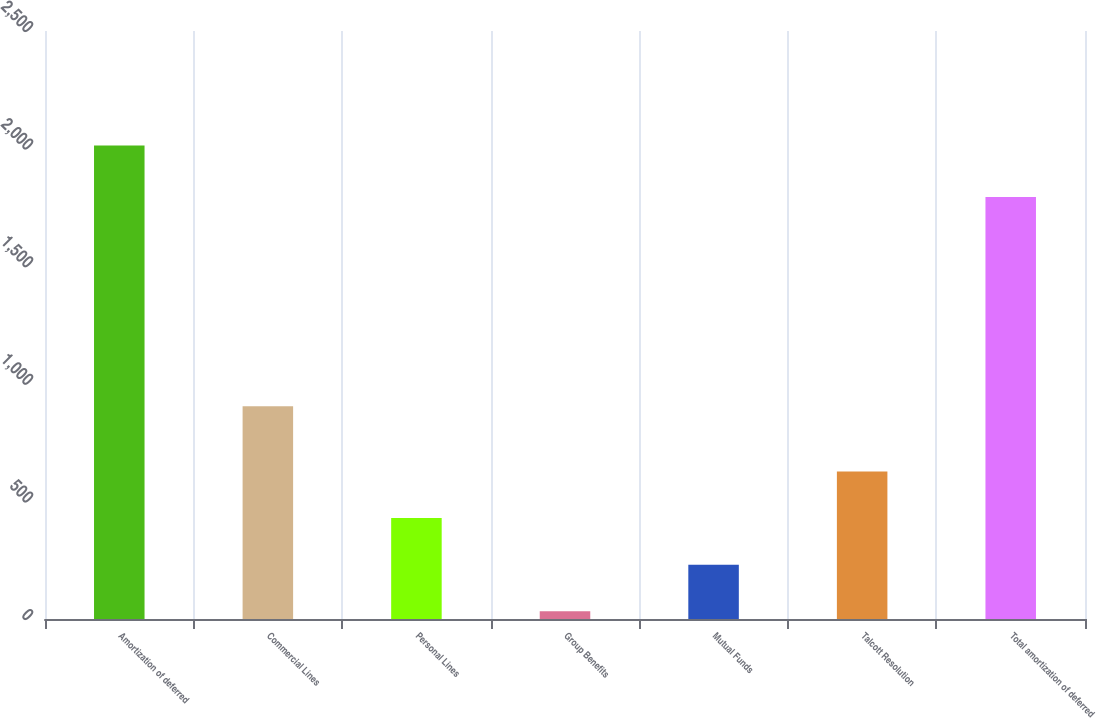<chart> <loc_0><loc_0><loc_500><loc_500><bar_chart><fcel>Amortization of deferred<fcel>Commercial Lines<fcel>Personal Lines<fcel>Group Benefits<fcel>Mutual Funds<fcel>Talcott Resolution<fcel>Total amortization of deferred<nl><fcel>2013<fcel>905<fcel>429<fcel>33<fcel>231<fcel>627<fcel>1794<nl></chart> 